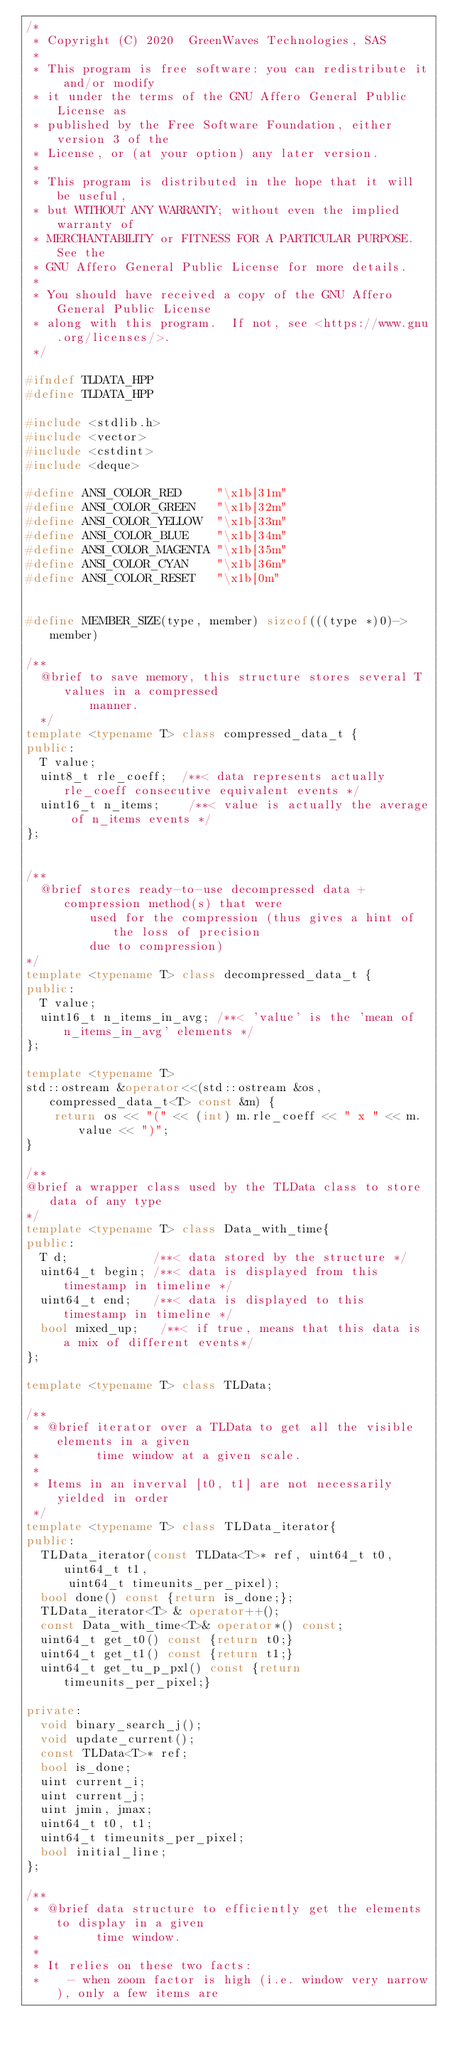Convert code to text. <code><loc_0><loc_0><loc_500><loc_500><_C++_>/*
 * Copyright (C) 2020  GreenWaves Technologies, SAS
 *
 * This program is free software: you can redistribute it and/or modify
 * it under the terms of the GNU Affero General Public License as
 * published by the Free Software Foundation, either version 3 of the
 * License, or (at your option) any later version.
 *
 * This program is distributed in the hope that it will be useful,
 * but WITHOUT ANY WARRANTY; without even the implied warranty of
 * MERCHANTABILITY or FITNESS FOR A PARTICULAR PURPOSE.  See the
 * GNU Affero General Public License for more details.
 *
 * You should have received a copy of the GNU Affero General Public License
 * along with this program.  If not, see <https://www.gnu.org/licenses/>.
 */

#ifndef TLDATA_HPP
#define TLDATA_HPP

#include <stdlib.h>
#include <vector>
#include <cstdint>
#include <deque>

#define ANSI_COLOR_RED     "\x1b[31m"
#define ANSI_COLOR_GREEN   "\x1b[32m"
#define ANSI_COLOR_YELLOW  "\x1b[33m"
#define ANSI_COLOR_BLUE    "\x1b[34m"
#define ANSI_COLOR_MAGENTA "\x1b[35m"
#define ANSI_COLOR_CYAN    "\x1b[36m"
#define ANSI_COLOR_RESET   "\x1b[0m"


#define MEMBER_SIZE(type, member) sizeof(((type *)0)->member)

/**
  @brief to save memory, this structure stores several T values in a compressed
         manner.
  */
template <typename T> class compressed_data_t {
public:
  T value;
  uint8_t rle_coeff;  /**< data represents actually rle_coeff consecutive equivalent events */
  uint16_t n_items;    /**< value is actually the average of n_items events */
};


/**
  @brief stores ready-to-use decompressed data + compression method(s) that were
         used for the compression (thus gives a hint of the loss of precision
         due to compression)
*/
template <typename T> class decompressed_data_t {
public:
  T value;
  uint16_t n_items_in_avg; /**< 'value' is the 'mean of n_items_in_avg' elements */
};

template <typename T>
std::ostream &operator<<(std::ostream &os, compressed_data_t<T> const &m) {
    return os << "(" << (int) m.rle_coeff << " x " << m.value << ")";
}

/**
@brief a wrapper class used by the TLData class to store data of any type
*/
template <typename T> class Data_with_time{
public:
  T d;            /**< data stored by the structure */
  uint64_t begin; /**< data is displayed from this timestamp in timeline */
  uint64_t end;   /**< data is displayed to this timestamp in timeline */
  bool mixed_up;   /**< if true, means that this data is a mix of different events*/
};

template <typename T> class TLData;

/**
 * @brief iterator over a TLData to get all the visible elements in a given
 *        time window at a given scale.
 *
 * Items in an inverval [t0, t1] are not necessarily yielded in order
 */
template <typename T> class TLData_iterator{
public:
  TLData_iterator(const TLData<T>* ref, uint64_t t0, uint64_t t1,
      uint64_t timeunits_per_pixel);
  bool done() const {return is_done;};
  TLData_iterator<T> & operator++();
  const Data_with_time<T>& operator*() const;
  uint64_t get_t0() const {return t0;}
  uint64_t get_t1() const {return t1;}
  uint64_t get_tu_p_pxl() const {return timeunits_per_pixel;}

private:
  void binary_search_j();
  void update_current();
  const TLData<T>* ref;
  bool is_done;
  uint current_i;
  uint current_j;
  uint jmin, jmax;
  uint64_t t0, t1;
  uint64_t timeunits_per_pixel;
  bool initial_line;
};

/**
 * @brief data structure to efficiently get the elements to display in a given
 *        time window.
 *
 * It relies on these two facts:
 *    - when zoom factor is high (i.e. window very narrow), only a few items are</code> 